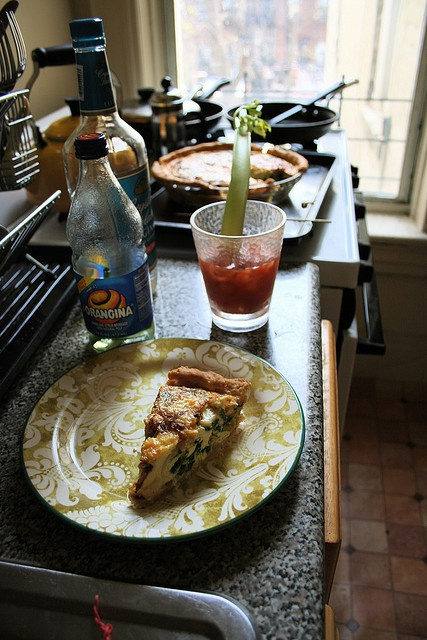Describe the objects in this image and their specific colors. I can see bottle in gray, black, darkgreen, and maroon tones, sink in gray, black, and maroon tones, pizza in gray, black, maroon, and olive tones, oven in gray, black, and lavender tones, and cup in gray, maroon, darkgray, white, and olive tones in this image. 